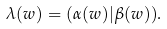<formula> <loc_0><loc_0><loc_500><loc_500>\lambda ( w ) = ( \alpha ( w ) | \beta ( w ) ) .</formula> 